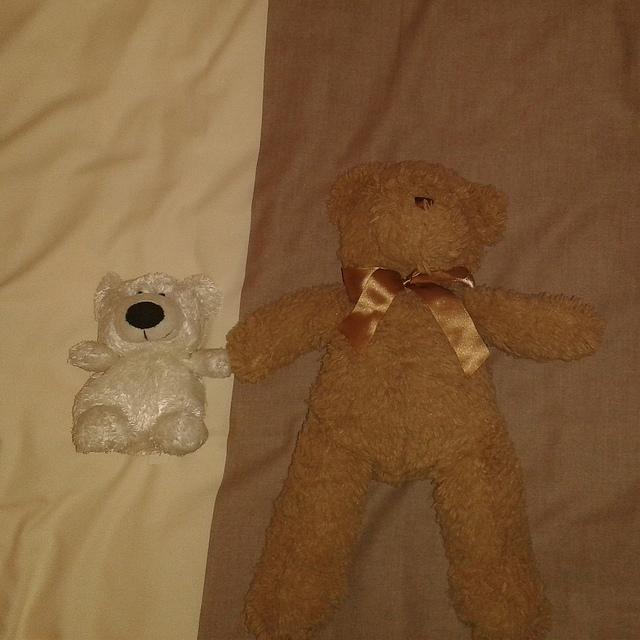Are the bears in the woods?
Answer briefly. No. Are the bears all about the same size?
Keep it brief. No. What color is the smaller bear?
Quick response, please. White. Which bear has visible eyes?
Answer briefly. White. 